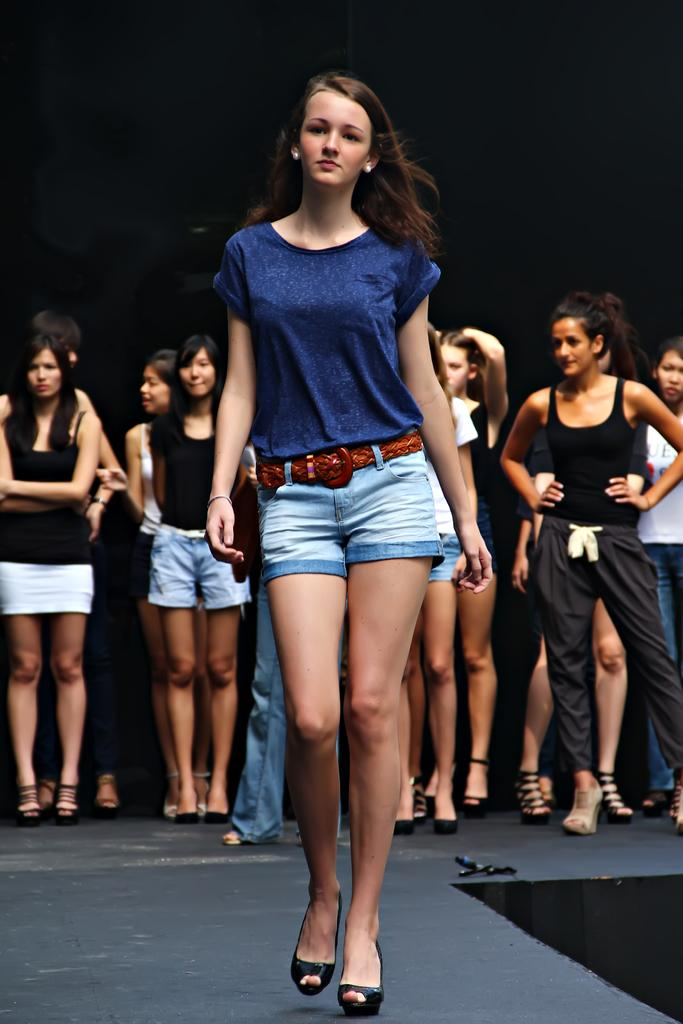Who is the main subject in the image? There is a girl in the image. What is the girl doing in the image? The girl is walking on a ramp. What is the girl wearing on her upper body? The girl is wearing a blue color top. What type of bottom clothing is the girl wearing? The girl is wearing shorts. Are there any other people visible in the image? Yes, there are girls standing in the background of the image. What type of company does the girl represent in the image? There is no indication in the image that the girl represents any company. What beliefs does the girl hold, as depicted in the image? The image does not provide any information about the girl's beliefs. 